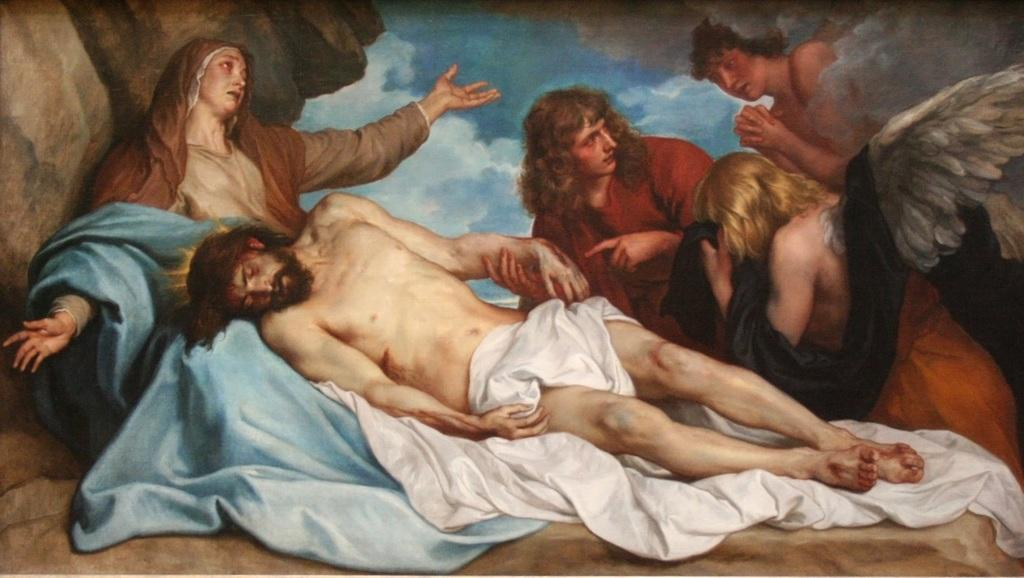What is the main subject of the image? The image contains a painting. What is happening in the painting? The painting depicts a man laying on a woman's lap. How is the man in the painting covered? The man in the painting is covered with cloth. Are there any other people in the painting? Yes, there are people standing beside the man in the painting. What can be seen in the background of the painting? The painting has a background with clouds. Can you tell me how many toes the man in the painting has? There is no information about the man's toes in the image, as the focus is on the scene depicted in the painting. --- Facts: 1. There is a car in the image. 2. The car is parked on the street. 3. The car has a flat tire. 4. There are people walking on the sidewalk. 5. The image is taken during the day. Absurd Topics: fish, ocean, waves Conversation: What is the main subject of the image? The main subject of the image is a car. Where is the car located in the image? The car is parked on the street. What is the condition of the car in the image? The car has a flat tire. Are there any people visible in the image? Yes, there are people walking on the sidewalk. What time of day is the image taken? The image is taken during the day. Reasoning: Let's think step by step in order to produce the conversation. We start by identifying the main subject of the image, which is the car. Then, we describe the location of the car, noting that it is parked on the street. Next, we mention the condition of the car, which has a flat tire. We also acknowledge the presence of people walking on the sidewalk and the time of day, which is during the day. Absurd Question/Answer: Can you tell me how many fish can be seen swimming in the ocean in the image? There is no ocean or fish present in the image; it features a car with a flat tire parked on the street. 